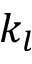Convert formula to latex. <formula><loc_0><loc_0><loc_500><loc_500>k _ { l }</formula> 